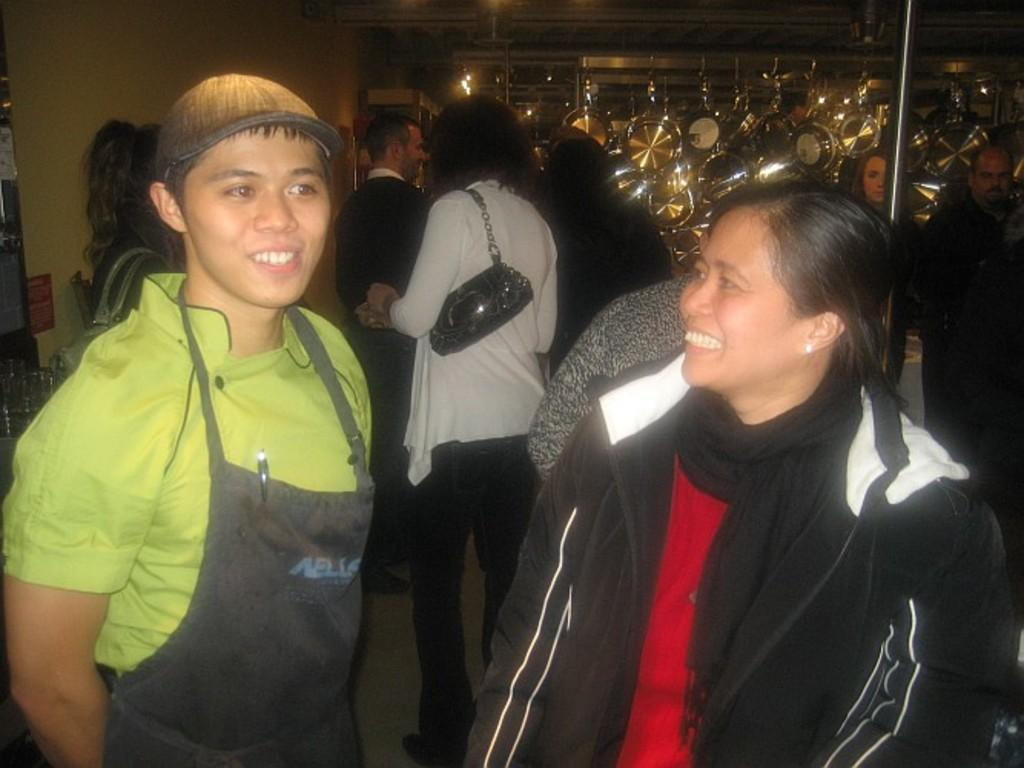Who or what can be seen in the image? There are people in the image. What objects are present in the image? There are pans and a pole in the image. What part of the natural environment is visible in the image? The sky is visible in the image. What type of prose is being recited by the people in the image? There is no indication in the image that the people are reciting any prose, so it cannot be determined from the picture. 